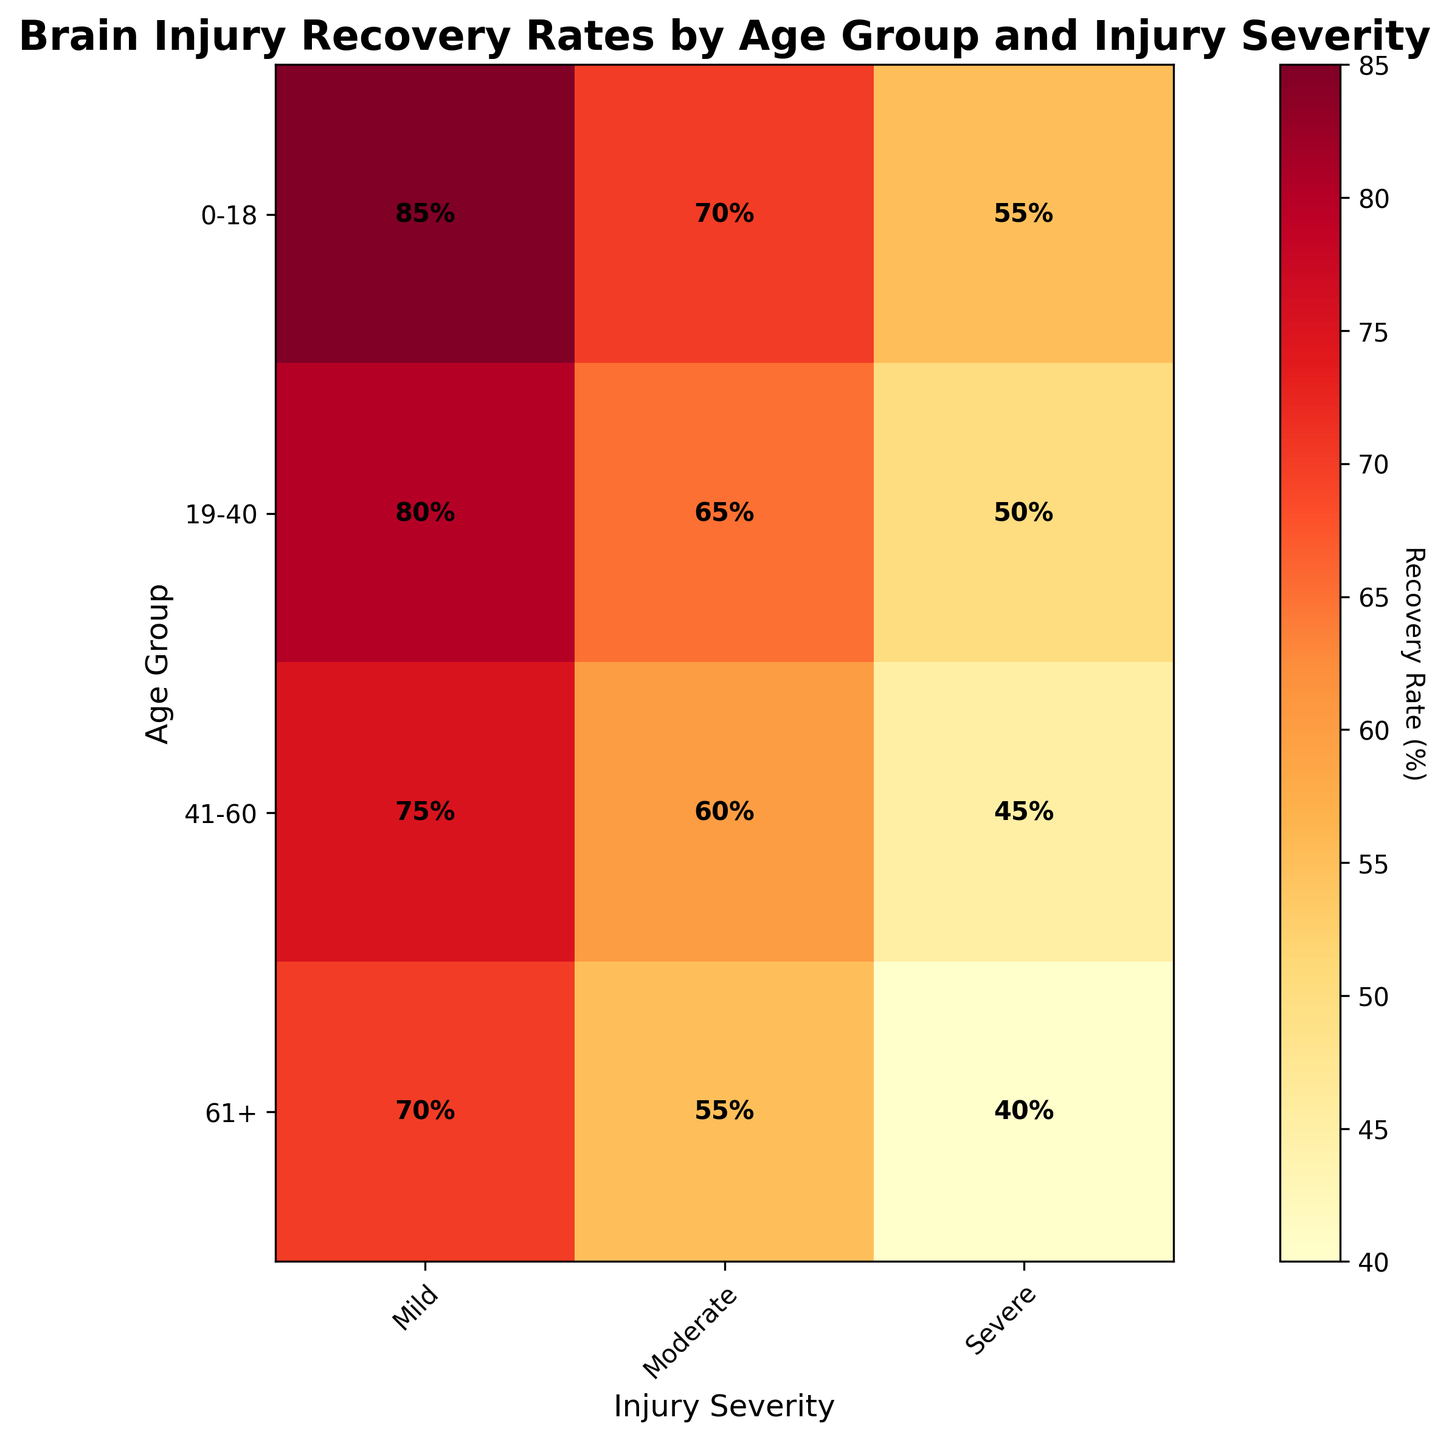What is the title of the figure? The title is displayed at the top of the figure in bold font.
Answer: Brain Injury Recovery Rates by Age Group and Injury Severity Which age group has the highest recovery rate for mild injuries? Look for the highest percentage in the "Mild" column.
Answer: 0-18 What is the recovery rate for severe injuries in the 61+ age group? Locate the "61+" row and check the "Severe" column.
Answer: 40% How does the recovery rate for moderate injuries compare between the 0-18 and 41-60 age groups? Check the "Moderate" column for both age groups and compare the numbers.
Answer: Higher in 0-18 Which age group has the lowest recovery rate for moderate injuries? Find the lowest percentage in the "Moderate" column across all age groups.
Answer: 61+ What's the average recovery rate for severe injuries across all age groups? Sum the percentages in the "Severe" column and divide by the number of age groups: (55+50+45+40)/4 = 47.5%
Answer: 47.5% Is the recovery rate for moderate injuries always higher than for severe injuries across all age groups? Compare the percentages for "Moderate" and "Severe" within each age group.
Answer: Yes How does the recovery rate change with age for mild injuries? Observe the "Mild" column and check the trend as age increases.
Answer: Decreases Among all groups, where does the 19-40 age group fall in terms of recovery rate for moderate injuries? Find the recovery rate for "Moderate" in the 19-40 group and see where it stands relative to other groups.
Answer: 2nd highest 